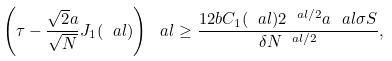Convert formula to latex. <formula><loc_0><loc_0><loc_500><loc_500>\left ( \tau - \frac { \sqrt { 2 } a } { \sqrt { N } } J _ { 1 } ( \ a l ) \right ) ^ { \ } a l \geq \frac { 1 2 b C _ { 1 } ( \ a l ) 2 ^ { \ a l / 2 } a ^ { \ } a l \sigma S } { \delta N ^ { \ a l / 2 } } ,</formula> 